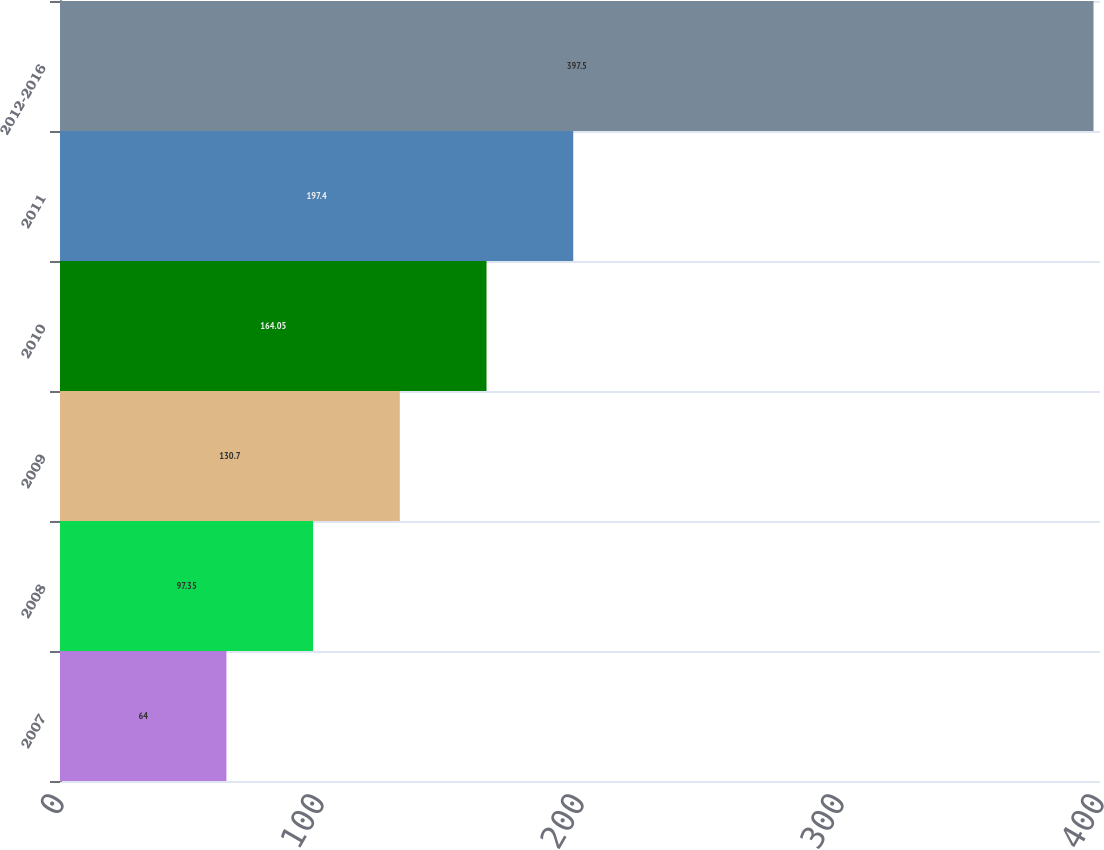Convert chart. <chart><loc_0><loc_0><loc_500><loc_500><bar_chart><fcel>2007<fcel>2008<fcel>2009<fcel>2010<fcel>2011<fcel>2012-2016<nl><fcel>64<fcel>97.35<fcel>130.7<fcel>164.05<fcel>197.4<fcel>397.5<nl></chart> 